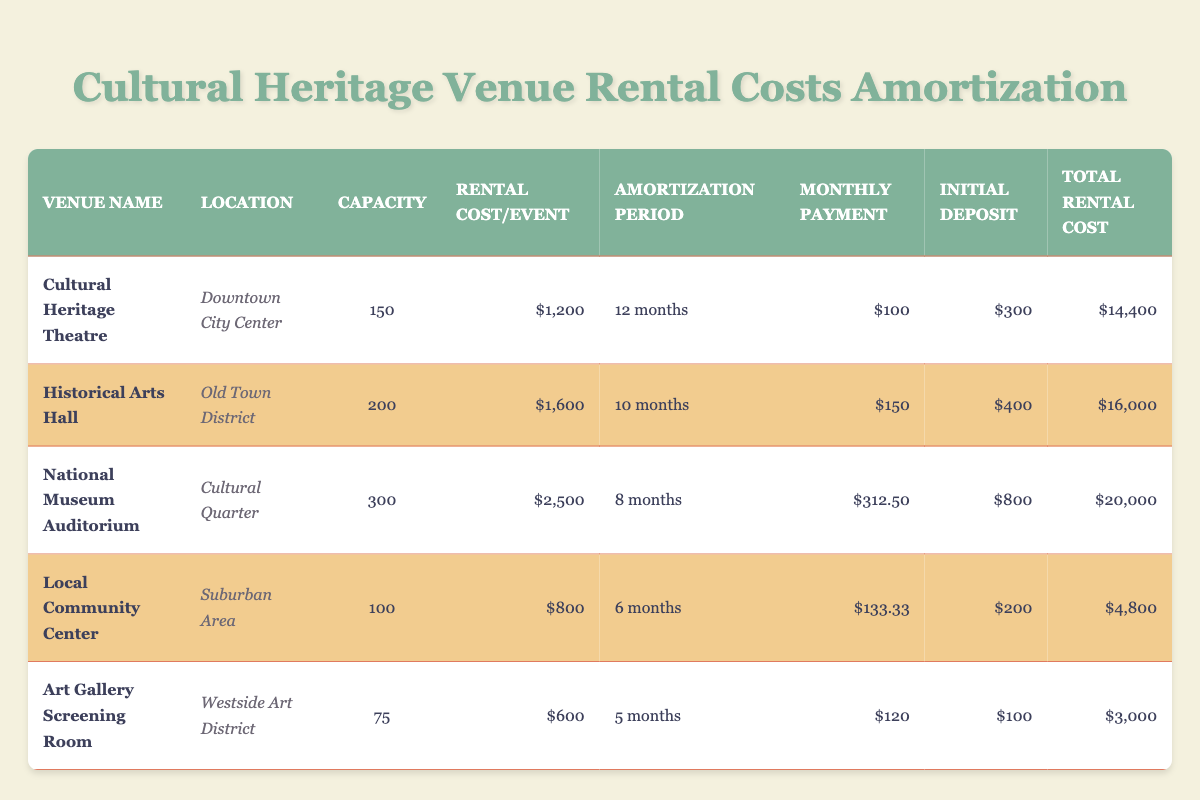What is the total rental cost for the Cultural Heritage Theatre? The table lists the total rental cost for the Cultural Heritage Theatre as $14,400. Therefore, this value is extracted directly from the table.
Answer: 14,400 What is the monthly payment for the National Museum Auditorium? The table shows that the monthly payment for the National Museum Auditorium is $312.50. This value is found in the corresponding row for that venue.
Answer: 312.50 How long is the amortization period for the Historical Arts Hall? The table indicates that the amortization period for the Historical Arts Hall is 10 months. This information is available in the relevant row for that venue.
Answer: 10 months Which venue has the highest capacity? By comparing the capacities listed in the table, the National Museum Auditorium has the highest capacity of 300. This is determined by checking the capacity column for all venues.
Answer: 300 What is the difference in total rental cost between the Local Community Center and the Art Gallery Screening Room? The total rental cost for the Local Community Center is $4,800, and for the Art Gallery Screening Room, it is $3,000. The difference is calculated as $4,800 - $3,000 = $1,800.
Answer: 1,800 Is the initial deposit for the Cultural Heritage Theatre greater than that for the Local Community Center? The initial deposit for the Cultural Heritage Theatre is $300, while for the Local Community Center, it is $200. Since $300 is greater than $200, the statement is true.
Answer: Yes What is the average rental cost per event for all venues? The rental costs per event are $1,200, $1,600, $2,500, $800, and $600. Adding these gives a total of $6,700. There are 5 venues, so the average is $6,700 / 5 = $1,340.
Answer: 1,340 How much is the total of the initial deposits for all venues? The initial deposits are $300, $400, $800, $200, and $100. Adding these values gives a total of $300 + $400 + $800 + $200 + $100 = $1,800.
Answer: 1,800 Which venue has the lowest monthly payment, and what is that payment? The Local Community Center has a monthly payment of $133.33, which is the lowest among all venues listed in the table. This is determined by comparing the monthly payments in each row.
Answer: 133.33 